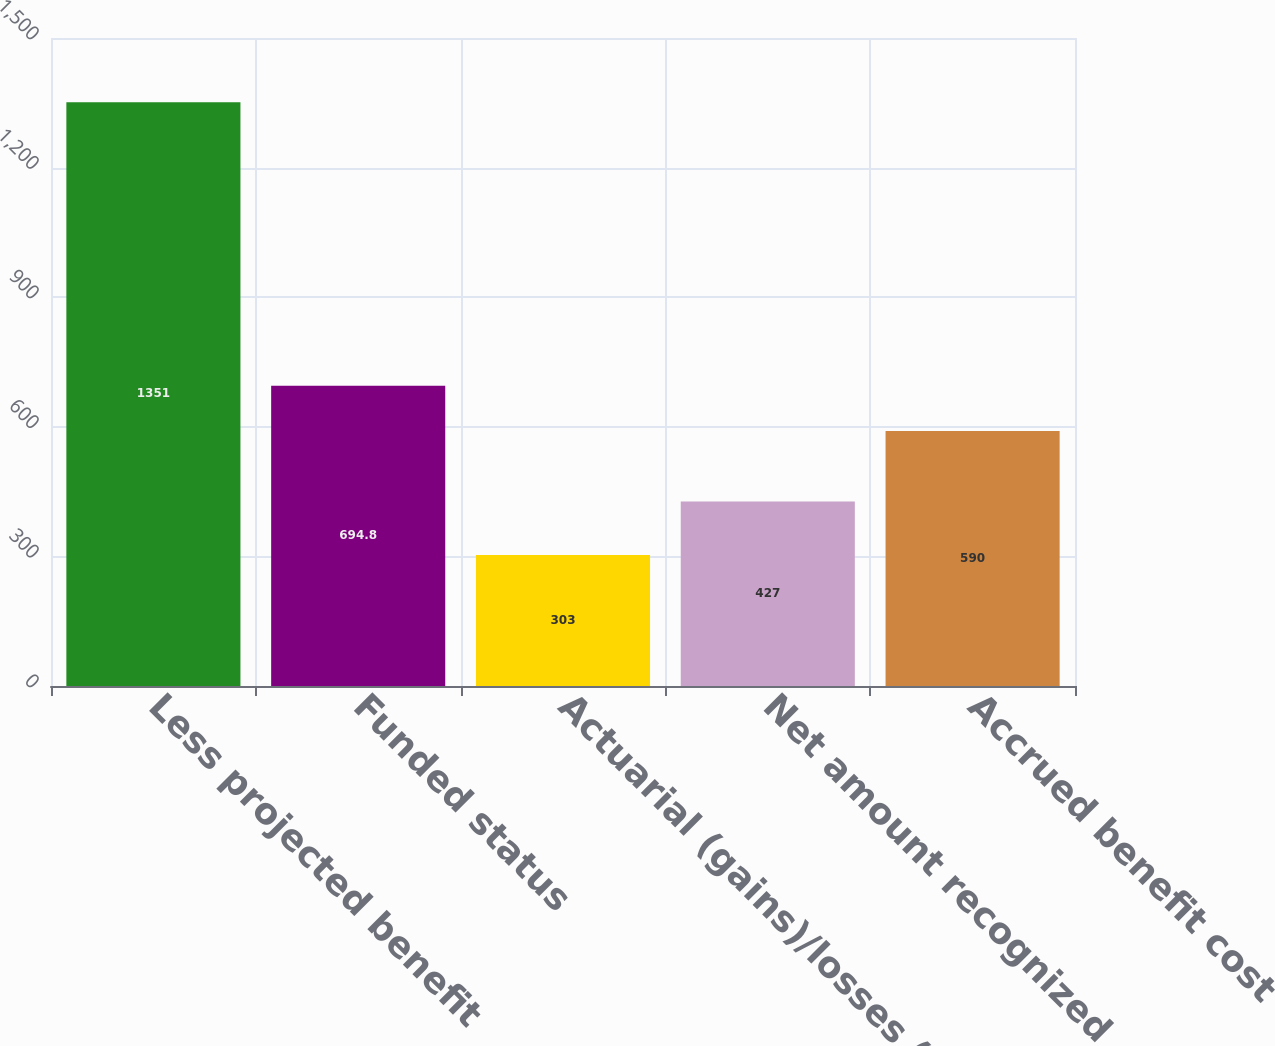Convert chart. <chart><loc_0><loc_0><loc_500><loc_500><bar_chart><fcel>Less projected benefit<fcel>Funded status<fcel>Actuarial (gains)/losses (c)<fcel>Net amount recognized<fcel>Accrued benefit cost<nl><fcel>1351<fcel>694.8<fcel>303<fcel>427<fcel>590<nl></chart> 